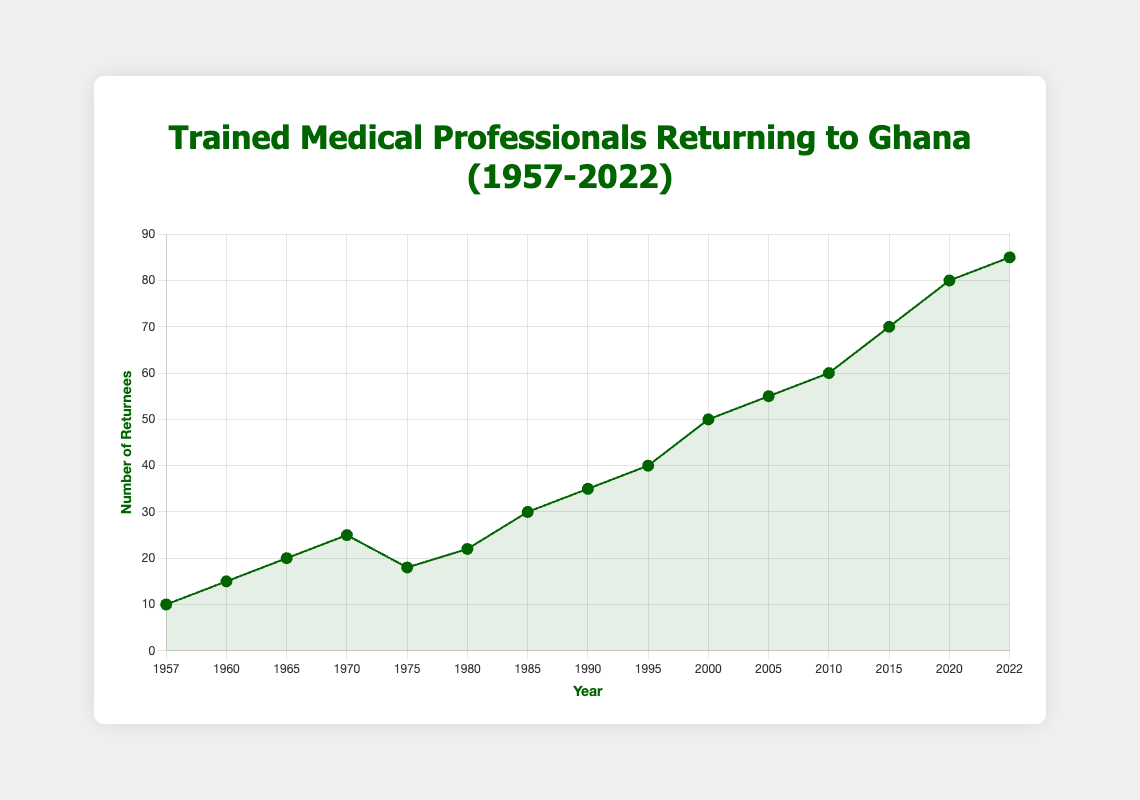What is the general trend in the number of trained medical professionals returning to Ghana from 1957 to 2022? To determine the general trend, observe the overall direction of the data points in the line chart. The line chart shows an upward trend overall, indicating an increase in the number of medical professionals returning to Ghana over time.
Answer: Upward trend How many more returnees were there in 2020 compared to 1960? Find the number of returnees in 2020 (80) and in 1960 (15). Subtract the number in 1960 from the number in 2020: 80 - 15 = 65.
Answer: 65 What is the average number of returnees in the years 1957, 1960, and 1965? Add the number of returnees in 1957 (10), 1960 (15), and 1965 (20). Calculate the average: (10 + 15 + 20) / 3 = 45 / 3 = 15.
Answer: 15 During which time period did the number of returnees show the greatest increase? Examine the differences between consecutive years. The largest increase occurred between 2010 (60) and 2015 (70), with an increase of 10.
Answer: 2010 to 2015 What is the slope of the line between 1985 and 1990? The number of returnees in 1985 was 30 and in 1990 was 35. The slope is calculated as the change in number of returnees divided by the change in years: (35 - 30) / (1990 - 1985) = 5 / 5 = 1.
Answer: 1 In which year does the chart depict the lowest number of returnees? Review the line chart and identify the data point with the lowest value, which is in 1957 with 10 returnees.
Answer: 1957 What is the median number of returnees from 1957 to 2022? List all the returnee values in ascending order: [10, 15, 18, 20, 22, 25, 30, 35, 40, 50, 55, 60, 70, 80, 85]. The median is the middle value, which is the 8th one in this 15-item list: 35.
Answer: 35 How did the number of returnees change from 1970 to 1975? The number of returnees in 1970 was 25 and in 1975 was 18. To find the change, subtract the 1975 value from the 1970 value: 18 - 25 = -7. So, there was a decrease of 7 returnees.
Answer: Decrease by 7 Which decade saw the highest average number of returnees? Calculate the average number of returnees for each decade. The 2010s (including 2022):
2010s: (60 + 70 + 80 + 85) / 4 = 295 / 4 = 73.75
The highest average occurs in the 2010s with 73.75.
Answer: 2010s 